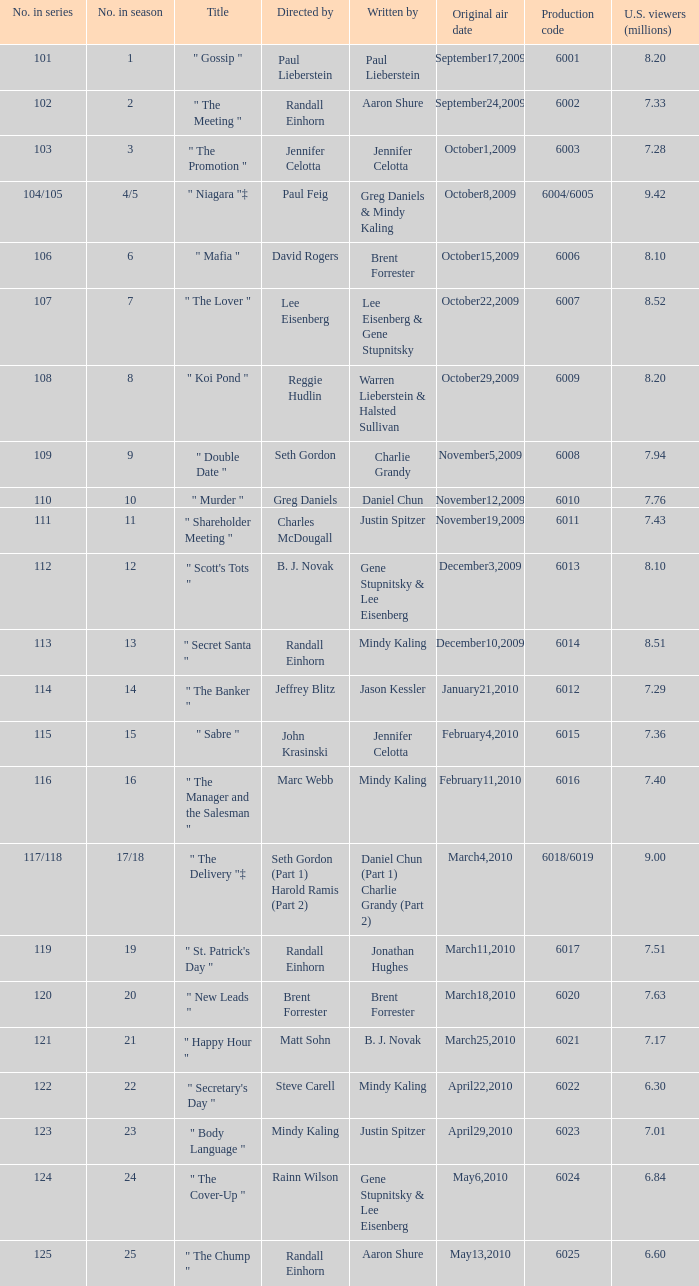Name the production code by paul lieberstein 6001.0. 